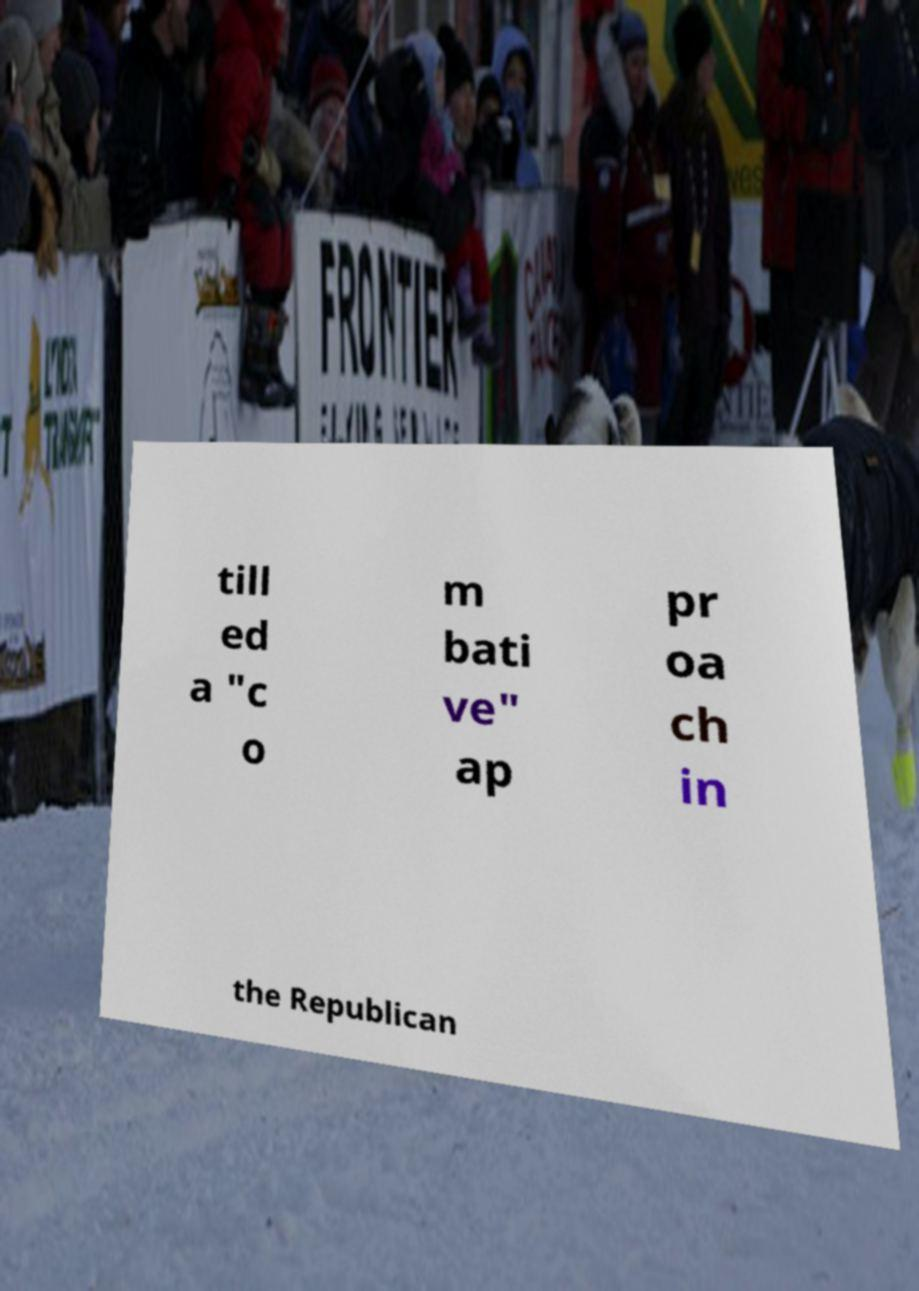Could you assist in decoding the text presented in this image and type it out clearly? till ed a "c o m bati ve" ap pr oa ch in the Republican 